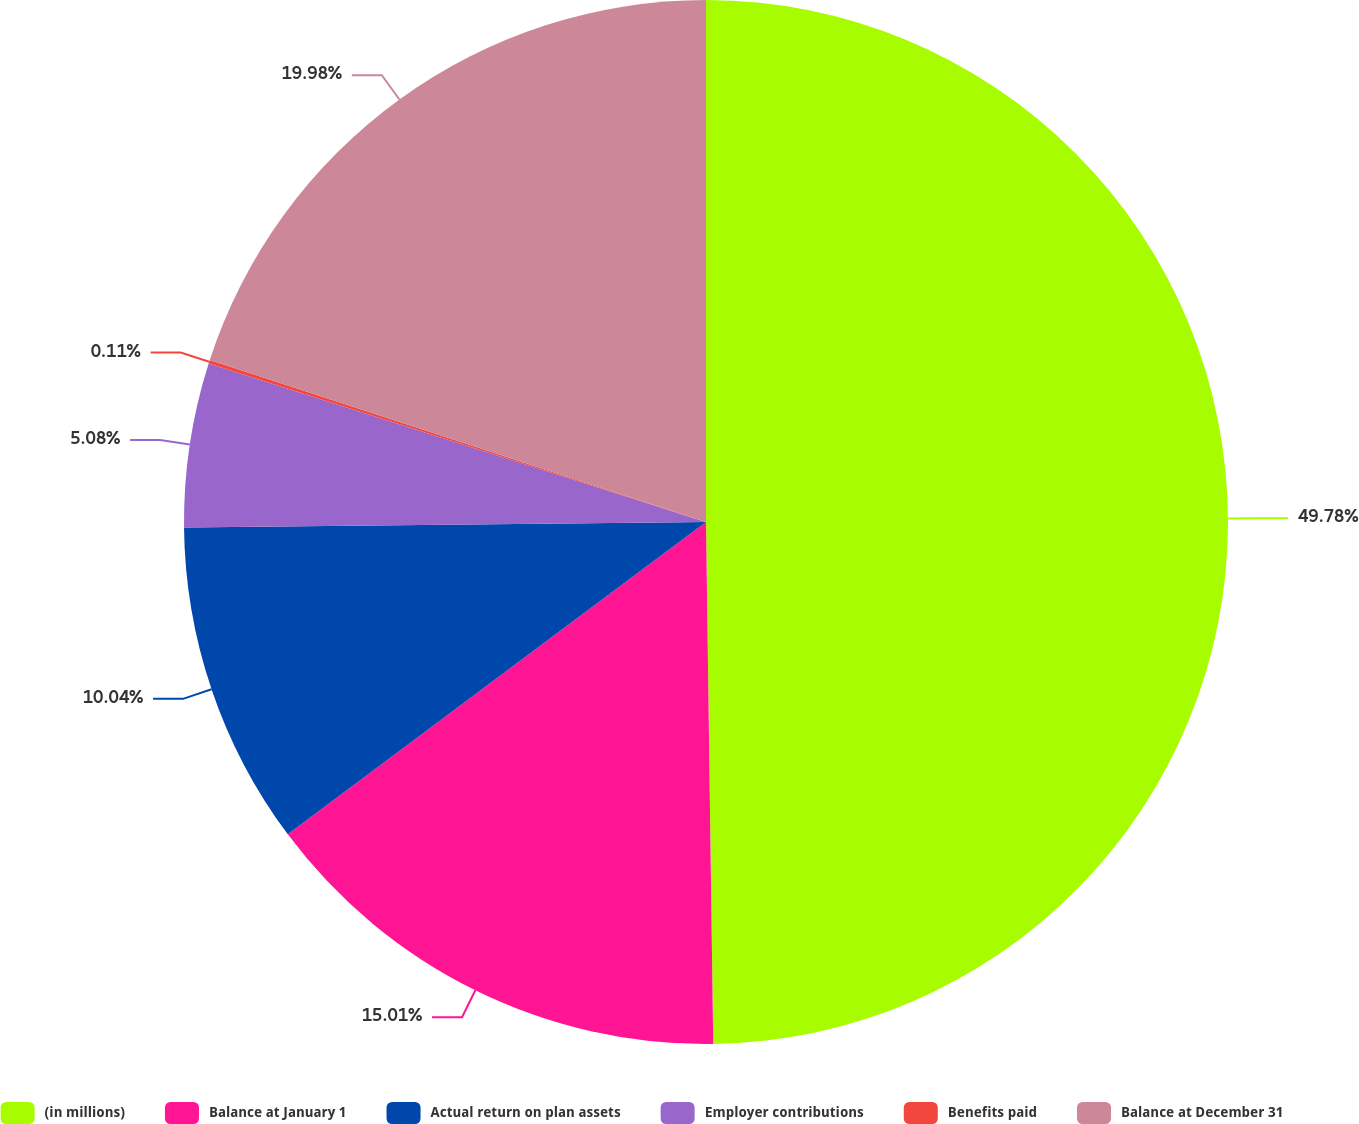Convert chart. <chart><loc_0><loc_0><loc_500><loc_500><pie_chart><fcel>(in millions)<fcel>Balance at January 1<fcel>Actual return on plan assets<fcel>Employer contributions<fcel>Benefits paid<fcel>Balance at December 31<nl><fcel>49.78%<fcel>15.01%<fcel>10.04%<fcel>5.08%<fcel>0.11%<fcel>19.98%<nl></chart> 